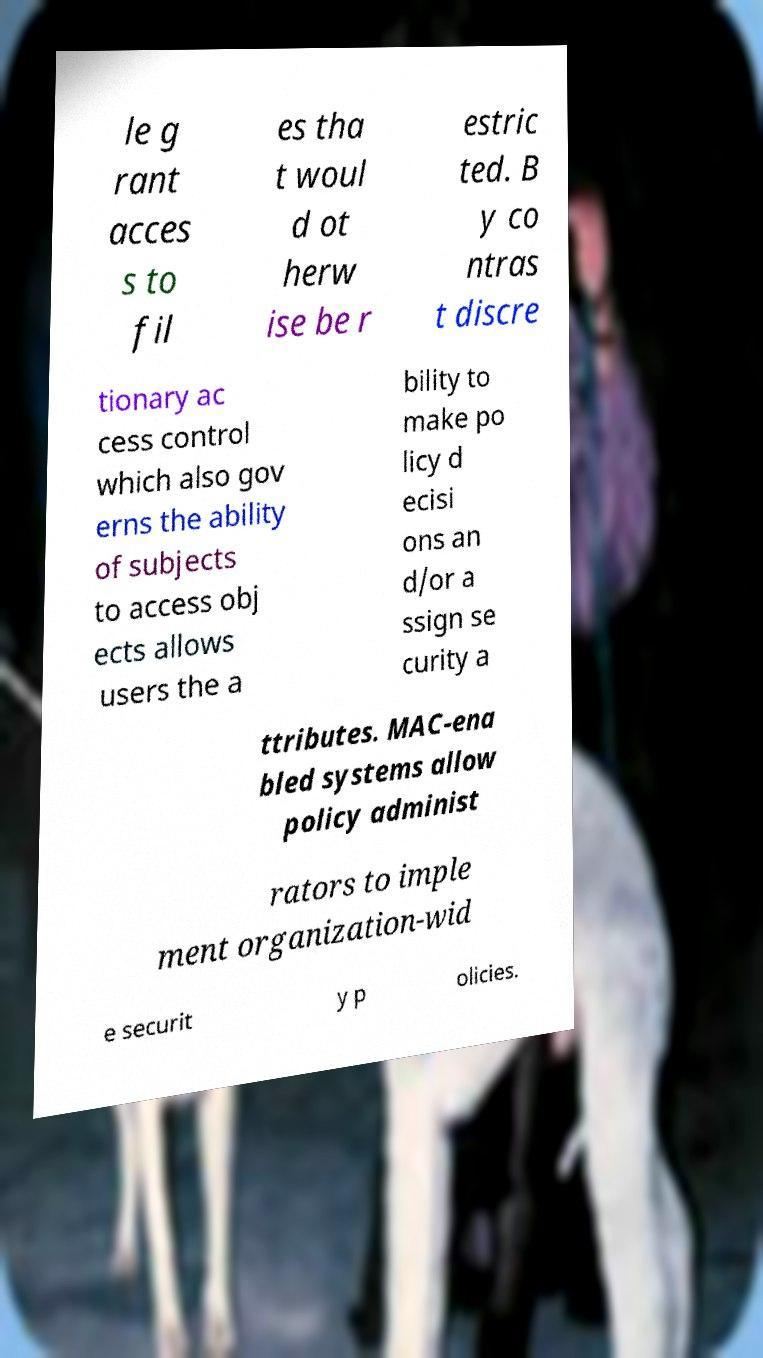Can you read and provide the text displayed in the image?This photo seems to have some interesting text. Can you extract and type it out for me? le g rant acces s to fil es tha t woul d ot herw ise be r estric ted. B y co ntras t discre tionary ac cess control which also gov erns the ability of subjects to access obj ects allows users the a bility to make po licy d ecisi ons an d/or a ssign se curity a ttributes. MAC-ena bled systems allow policy administ rators to imple ment organization-wid e securit y p olicies. 